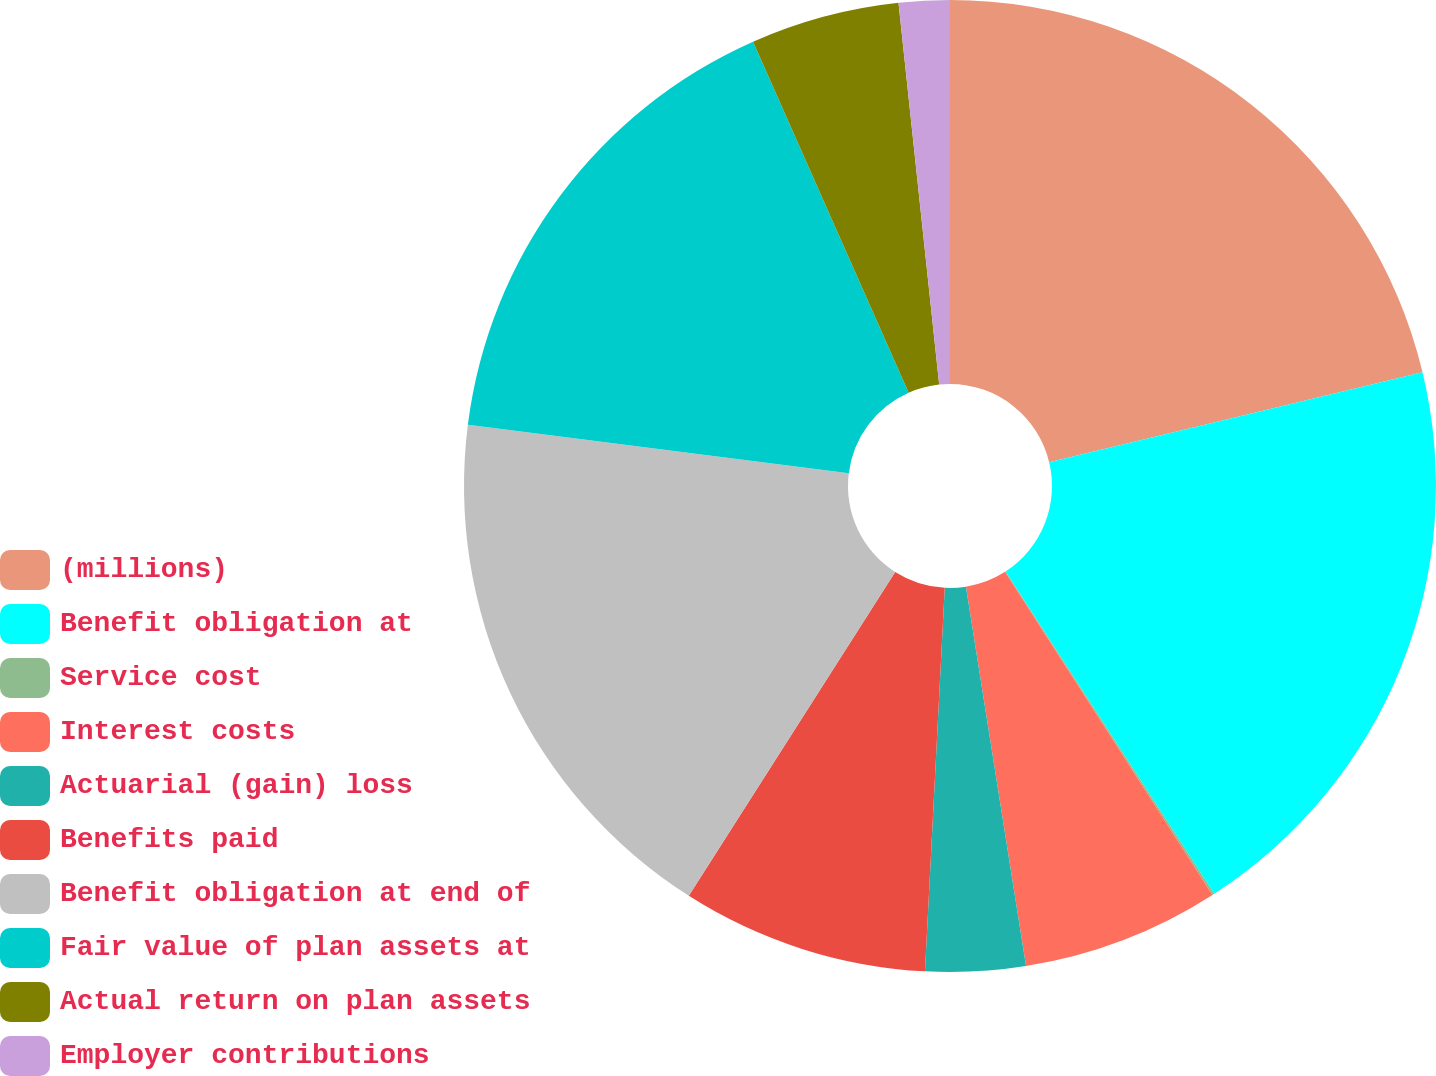<chart> <loc_0><loc_0><loc_500><loc_500><pie_chart><fcel>(millions)<fcel>Benefit obligation at<fcel>Service cost<fcel>Interest costs<fcel>Actuarial (gain) loss<fcel>Benefits paid<fcel>Benefit obligation at end of<fcel>Fair value of plan assets at<fcel>Actual return on plan assets<fcel>Employer contributions<nl><fcel>21.24%<fcel>19.61%<fcel>0.07%<fcel>6.58%<fcel>3.32%<fcel>8.21%<fcel>17.98%<fcel>16.35%<fcel>4.95%<fcel>1.69%<nl></chart> 